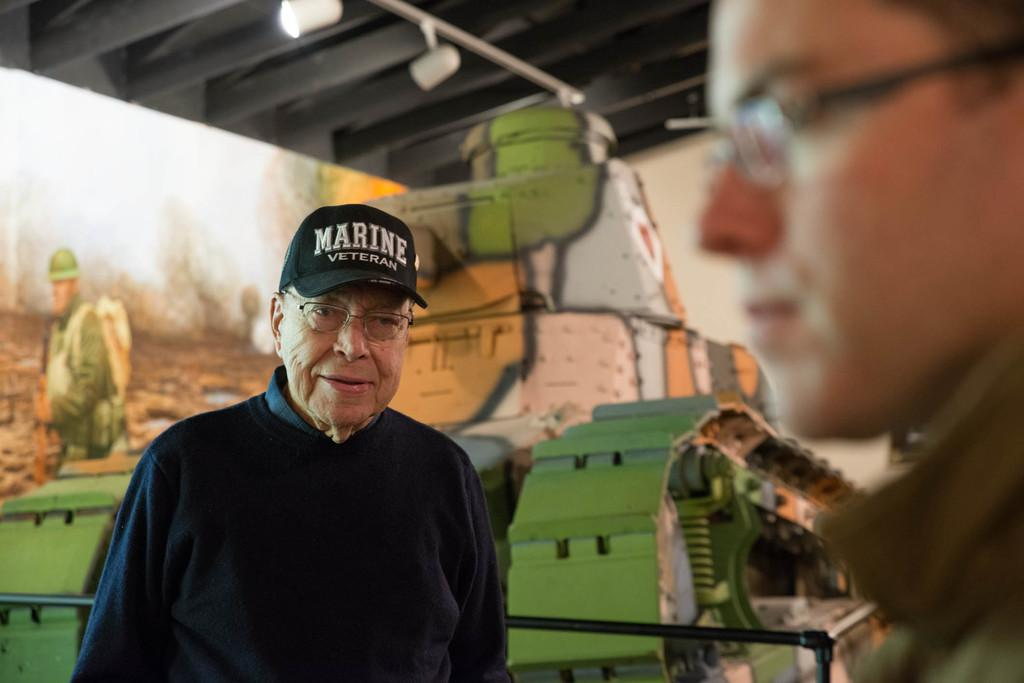What is located on the left side of the image? There is a person on the left side of the image. What can be observed about the person's appearance? The person is wearing spectacles. What is visible in the background of the image? There is a wall in the background of the image. Reasoning: Let's think step by step by step in order to produce the conversation. We start by identifying the main subject in the image, which is the person on the left side. Then, we describe a specific detail about the person's appearance, which is the spectacles they are wearing. Finally, we mention the background of the image, which includes a wall. Each question is designed to elicit a specific detail about the image that is known from the provided facts. Absurd Question/Answer: How does the person move around the hill in the image? There is no hill present in the image, and the person's movement is not depicted. What type of pan is being used by the person in the image? There is no pan visible in the image, and the person is not using any cooking utensils. How does the person move around the hill in the image? There is no hill present in the image, and the person's movement is not depicted. What type of pan is being used by the person in the image? There is no pan visible in the image, and the person is not using any cooking utensils. 